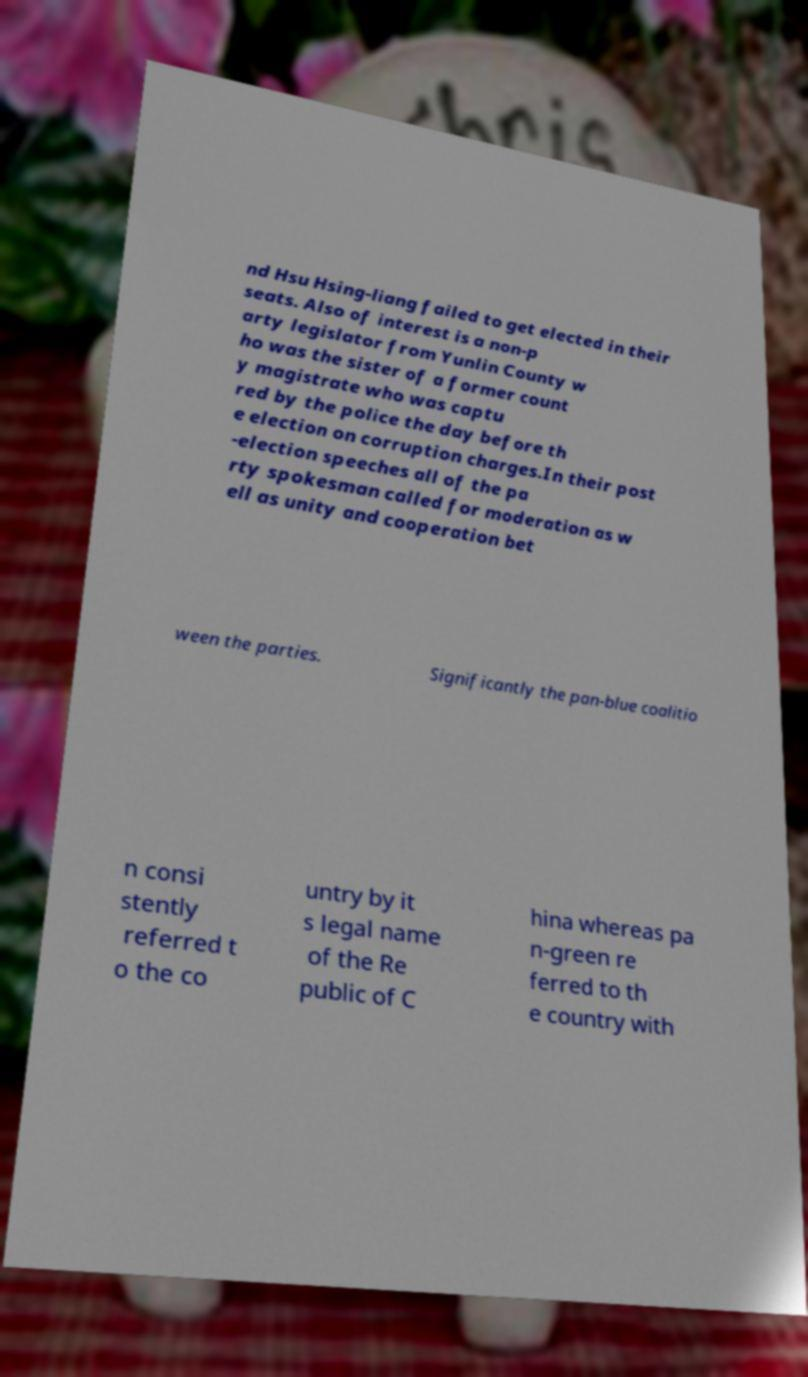Can you accurately transcribe the text from the provided image for me? nd Hsu Hsing-liang failed to get elected in their seats. Also of interest is a non-p arty legislator from Yunlin County w ho was the sister of a former count y magistrate who was captu red by the police the day before th e election on corruption charges.In their post -election speeches all of the pa rty spokesman called for moderation as w ell as unity and cooperation bet ween the parties. Significantly the pan-blue coalitio n consi stently referred t o the co untry by it s legal name of the Re public of C hina whereas pa n-green re ferred to th e country with 